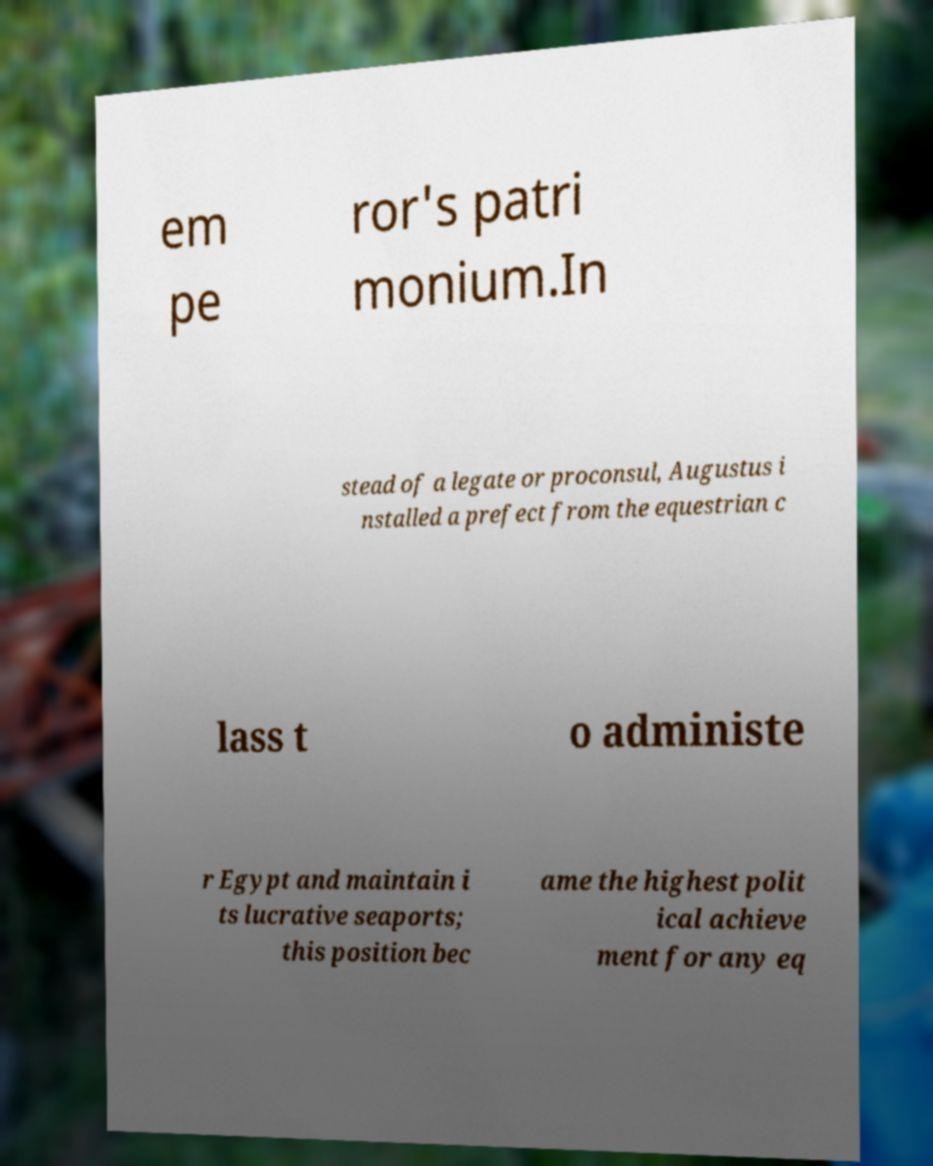What messages or text are displayed in this image? I need them in a readable, typed format. em pe ror's patri monium.In stead of a legate or proconsul, Augustus i nstalled a prefect from the equestrian c lass t o administe r Egypt and maintain i ts lucrative seaports; this position bec ame the highest polit ical achieve ment for any eq 